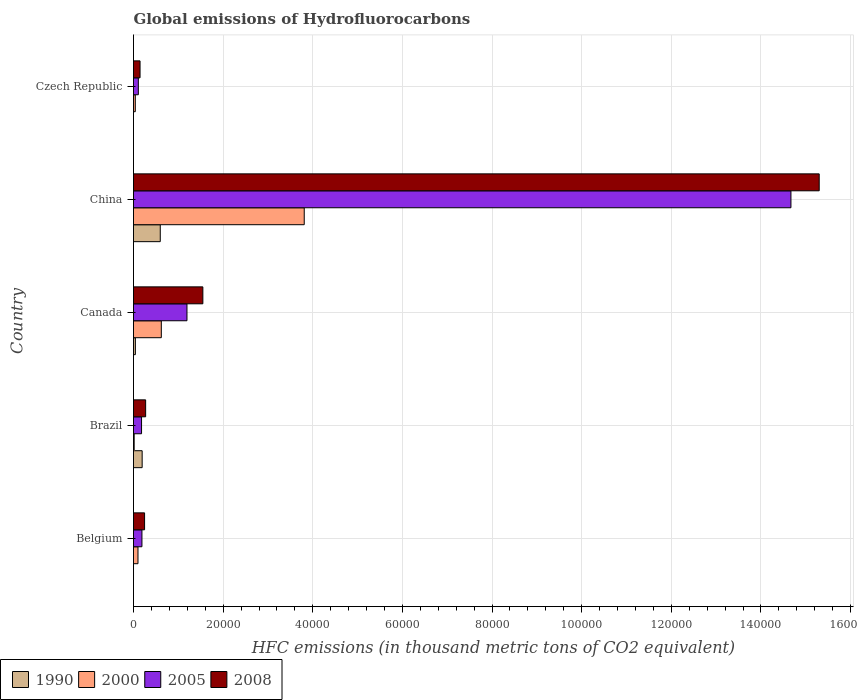How many different coloured bars are there?
Your answer should be very brief. 4. How many groups of bars are there?
Your answer should be very brief. 5. Are the number of bars per tick equal to the number of legend labels?
Your answer should be compact. Yes. How many bars are there on the 3rd tick from the top?
Give a very brief answer. 4. What is the global emissions of Hydrofluorocarbons in 2000 in Czech Republic?
Keep it short and to the point. 399.5. Across all countries, what is the maximum global emissions of Hydrofluorocarbons in 2005?
Your answer should be very brief. 1.47e+05. Across all countries, what is the minimum global emissions of Hydrofluorocarbons in 2005?
Your answer should be very brief. 1078.7. In which country was the global emissions of Hydrofluorocarbons in 2005 minimum?
Offer a terse response. Czech Republic. What is the total global emissions of Hydrofluorocarbons in 2008 in the graph?
Your answer should be compact. 1.75e+05. What is the difference between the global emissions of Hydrofluorocarbons in 2000 in Brazil and that in Canada?
Give a very brief answer. -6055.4. What is the difference between the global emissions of Hydrofluorocarbons in 2008 in Brazil and the global emissions of Hydrofluorocarbons in 1990 in Belgium?
Offer a very short reply. 2707. What is the average global emissions of Hydrofluorocarbons in 2000 per country?
Keep it short and to the point. 9168.28. What is the difference between the global emissions of Hydrofluorocarbons in 1990 and global emissions of Hydrofluorocarbons in 2005 in China?
Provide a short and direct response. -1.41e+05. In how many countries, is the global emissions of Hydrofluorocarbons in 1990 greater than 100000 thousand metric tons?
Provide a succinct answer. 0. What is the ratio of the global emissions of Hydrofluorocarbons in 2008 in Brazil to that in Canada?
Make the answer very short. 0.17. Is the global emissions of Hydrofluorocarbons in 1990 in Canada less than that in China?
Your response must be concise. Yes. What is the difference between the highest and the second highest global emissions of Hydrofluorocarbons in 2008?
Make the answer very short. 1.38e+05. What is the difference between the highest and the lowest global emissions of Hydrofluorocarbons in 1990?
Your response must be concise. 5970. In how many countries, is the global emissions of Hydrofluorocarbons in 1990 greater than the average global emissions of Hydrofluorocarbons in 1990 taken over all countries?
Offer a very short reply. 2. Is the sum of the global emissions of Hydrofluorocarbons in 2008 in Brazil and Czech Republic greater than the maximum global emissions of Hydrofluorocarbons in 2005 across all countries?
Your response must be concise. No. Is it the case that in every country, the sum of the global emissions of Hydrofluorocarbons in 1990 and global emissions of Hydrofluorocarbons in 2008 is greater than the sum of global emissions of Hydrofluorocarbons in 2000 and global emissions of Hydrofluorocarbons in 2005?
Provide a succinct answer. No. What does the 3rd bar from the bottom in Belgium represents?
Your response must be concise. 2005. Is it the case that in every country, the sum of the global emissions of Hydrofluorocarbons in 2000 and global emissions of Hydrofluorocarbons in 1990 is greater than the global emissions of Hydrofluorocarbons in 2008?
Provide a succinct answer. No. How many bars are there?
Offer a terse response. 20. Are all the bars in the graph horizontal?
Ensure brevity in your answer.  Yes. How many countries are there in the graph?
Ensure brevity in your answer.  5. Are the values on the major ticks of X-axis written in scientific E-notation?
Provide a short and direct response. No. Does the graph contain any zero values?
Provide a succinct answer. No. Does the graph contain grids?
Your answer should be compact. Yes. What is the title of the graph?
Ensure brevity in your answer.  Global emissions of Hydrofluorocarbons. What is the label or title of the X-axis?
Your answer should be compact. HFC emissions (in thousand metric tons of CO2 equivalent). What is the label or title of the Y-axis?
Keep it short and to the point. Country. What is the HFC emissions (in thousand metric tons of CO2 equivalent) in 2000 in Belgium?
Provide a short and direct response. 997.7. What is the HFC emissions (in thousand metric tons of CO2 equivalent) of 2005 in Belgium?
Provide a succinct answer. 1882.6. What is the HFC emissions (in thousand metric tons of CO2 equivalent) of 2008 in Belgium?
Provide a short and direct response. 2471.1. What is the HFC emissions (in thousand metric tons of CO2 equivalent) in 1990 in Brazil?
Offer a terse response. 1930.7. What is the HFC emissions (in thousand metric tons of CO2 equivalent) in 2000 in Brazil?
Your answer should be compact. 147.4. What is the HFC emissions (in thousand metric tons of CO2 equivalent) in 2005 in Brazil?
Ensure brevity in your answer.  1793.4. What is the HFC emissions (in thousand metric tons of CO2 equivalent) in 2008 in Brazil?
Your answer should be compact. 2707.5. What is the HFC emissions (in thousand metric tons of CO2 equivalent) in 1990 in Canada?
Your response must be concise. 418.5. What is the HFC emissions (in thousand metric tons of CO2 equivalent) of 2000 in Canada?
Your answer should be compact. 6202.8. What is the HFC emissions (in thousand metric tons of CO2 equivalent) in 2005 in Canada?
Offer a very short reply. 1.19e+04. What is the HFC emissions (in thousand metric tons of CO2 equivalent) in 2008 in Canada?
Offer a very short reply. 1.55e+04. What is the HFC emissions (in thousand metric tons of CO2 equivalent) in 1990 in China?
Your answer should be very brief. 5970.1. What is the HFC emissions (in thousand metric tons of CO2 equivalent) of 2000 in China?
Keep it short and to the point. 3.81e+04. What is the HFC emissions (in thousand metric tons of CO2 equivalent) of 2005 in China?
Your answer should be compact. 1.47e+05. What is the HFC emissions (in thousand metric tons of CO2 equivalent) of 2008 in China?
Keep it short and to the point. 1.53e+05. What is the HFC emissions (in thousand metric tons of CO2 equivalent) of 1990 in Czech Republic?
Provide a short and direct response. 0.1. What is the HFC emissions (in thousand metric tons of CO2 equivalent) of 2000 in Czech Republic?
Your answer should be compact. 399.5. What is the HFC emissions (in thousand metric tons of CO2 equivalent) of 2005 in Czech Republic?
Ensure brevity in your answer.  1078.7. What is the HFC emissions (in thousand metric tons of CO2 equivalent) of 2008 in Czech Republic?
Ensure brevity in your answer.  1459. Across all countries, what is the maximum HFC emissions (in thousand metric tons of CO2 equivalent) in 1990?
Provide a short and direct response. 5970.1. Across all countries, what is the maximum HFC emissions (in thousand metric tons of CO2 equivalent) of 2000?
Your response must be concise. 3.81e+04. Across all countries, what is the maximum HFC emissions (in thousand metric tons of CO2 equivalent) in 2005?
Your response must be concise. 1.47e+05. Across all countries, what is the maximum HFC emissions (in thousand metric tons of CO2 equivalent) in 2008?
Provide a succinct answer. 1.53e+05. Across all countries, what is the minimum HFC emissions (in thousand metric tons of CO2 equivalent) of 2000?
Make the answer very short. 147.4. Across all countries, what is the minimum HFC emissions (in thousand metric tons of CO2 equivalent) in 2005?
Offer a terse response. 1078.7. Across all countries, what is the minimum HFC emissions (in thousand metric tons of CO2 equivalent) of 2008?
Your response must be concise. 1459. What is the total HFC emissions (in thousand metric tons of CO2 equivalent) in 1990 in the graph?
Provide a succinct answer. 8319.9. What is the total HFC emissions (in thousand metric tons of CO2 equivalent) in 2000 in the graph?
Offer a very short reply. 4.58e+04. What is the total HFC emissions (in thousand metric tons of CO2 equivalent) of 2005 in the graph?
Ensure brevity in your answer.  1.63e+05. What is the total HFC emissions (in thousand metric tons of CO2 equivalent) of 2008 in the graph?
Ensure brevity in your answer.  1.75e+05. What is the difference between the HFC emissions (in thousand metric tons of CO2 equivalent) of 1990 in Belgium and that in Brazil?
Provide a succinct answer. -1930.2. What is the difference between the HFC emissions (in thousand metric tons of CO2 equivalent) of 2000 in Belgium and that in Brazil?
Give a very brief answer. 850.3. What is the difference between the HFC emissions (in thousand metric tons of CO2 equivalent) in 2005 in Belgium and that in Brazil?
Offer a terse response. 89.2. What is the difference between the HFC emissions (in thousand metric tons of CO2 equivalent) of 2008 in Belgium and that in Brazil?
Provide a short and direct response. -236.4. What is the difference between the HFC emissions (in thousand metric tons of CO2 equivalent) in 1990 in Belgium and that in Canada?
Ensure brevity in your answer.  -418. What is the difference between the HFC emissions (in thousand metric tons of CO2 equivalent) of 2000 in Belgium and that in Canada?
Keep it short and to the point. -5205.1. What is the difference between the HFC emissions (in thousand metric tons of CO2 equivalent) in 2005 in Belgium and that in Canada?
Your response must be concise. -1.00e+04. What is the difference between the HFC emissions (in thousand metric tons of CO2 equivalent) in 2008 in Belgium and that in Canada?
Your answer should be very brief. -1.30e+04. What is the difference between the HFC emissions (in thousand metric tons of CO2 equivalent) of 1990 in Belgium and that in China?
Your response must be concise. -5969.6. What is the difference between the HFC emissions (in thousand metric tons of CO2 equivalent) of 2000 in Belgium and that in China?
Give a very brief answer. -3.71e+04. What is the difference between the HFC emissions (in thousand metric tons of CO2 equivalent) of 2005 in Belgium and that in China?
Your answer should be very brief. -1.45e+05. What is the difference between the HFC emissions (in thousand metric tons of CO2 equivalent) in 2008 in Belgium and that in China?
Provide a succinct answer. -1.51e+05. What is the difference between the HFC emissions (in thousand metric tons of CO2 equivalent) in 1990 in Belgium and that in Czech Republic?
Provide a short and direct response. 0.4. What is the difference between the HFC emissions (in thousand metric tons of CO2 equivalent) of 2000 in Belgium and that in Czech Republic?
Keep it short and to the point. 598.2. What is the difference between the HFC emissions (in thousand metric tons of CO2 equivalent) of 2005 in Belgium and that in Czech Republic?
Give a very brief answer. 803.9. What is the difference between the HFC emissions (in thousand metric tons of CO2 equivalent) in 2008 in Belgium and that in Czech Republic?
Your response must be concise. 1012.1. What is the difference between the HFC emissions (in thousand metric tons of CO2 equivalent) of 1990 in Brazil and that in Canada?
Keep it short and to the point. 1512.2. What is the difference between the HFC emissions (in thousand metric tons of CO2 equivalent) of 2000 in Brazil and that in Canada?
Provide a succinct answer. -6055.4. What is the difference between the HFC emissions (in thousand metric tons of CO2 equivalent) of 2005 in Brazil and that in Canada?
Offer a very short reply. -1.01e+04. What is the difference between the HFC emissions (in thousand metric tons of CO2 equivalent) of 2008 in Brazil and that in Canada?
Your answer should be compact. -1.28e+04. What is the difference between the HFC emissions (in thousand metric tons of CO2 equivalent) in 1990 in Brazil and that in China?
Offer a terse response. -4039.4. What is the difference between the HFC emissions (in thousand metric tons of CO2 equivalent) in 2000 in Brazil and that in China?
Offer a very short reply. -3.79e+04. What is the difference between the HFC emissions (in thousand metric tons of CO2 equivalent) of 2005 in Brazil and that in China?
Ensure brevity in your answer.  -1.45e+05. What is the difference between the HFC emissions (in thousand metric tons of CO2 equivalent) of 2008 in Brazil and that in China?
Your response must be concise. -1.50e+05. What is the difference between the HFC emissions (in thousand metric tons of CO2 equivalent) in 1990 in Brazil and that in Czech Republic?
Ensure brevity in your answer.  1930.6. What is the difference between the HFC emissions (in thousand metric tons of CO2 equivalent) of 2000 in Brazil and that in Czech Republic?
Offer a very short reply. -252.1. What is the difference between the HFC emissions (in thousand metric tons of CO2 equivalent) in 2005 in Brazil and that in Czech Republic?
Your answer should be very brief. 714.7. What is the difference between the HFC emissions (in thousand metric tons of CO2 equivalent) of 2008 in Brazil and that in Czech Republic?
Make the answer very short. 1248.5. What is the difference between the HFC emissions (in thousand metric tons of CO2 equivalent) in 1990 in Canada and that in China?
Your answer should be compact. -5551.6. What is the difference between the HFC emissions (in thousand metric tons of CO2 equivalent) in 2000 in Canada and that in China?
Offer a terse response. -3.19e+04. What is the difference between the HFC emissions (in thousand metric tons of CO2 equivalent) in 2005 in Canada and that in China?
Provide a succinct answer. -1.35e+05. What is the difference between the HFC emissions (in thousand metric tons of CO2 equivalent) in 2008 in Canada and that in China?
Keep it short and to the point. -1.38e+05. What is the difference between the HFC emissions (in thousand metric tons of CO2 equivalent) in 1990 in Canada and that in Czech Republic?
Provide a short and direct response. 418.4. What is the difference between the HFC emissions (in thousand metric tons of CO2 equivalent) in 2000 in Canada and that in Czech Republic?
Ensure brevity in your answer.  5803.3. What is the difference between the HFC emissions (in thousand metric tons of CO2 equivalent) in 2005 in Canada and that in Czech Republic?
Keep it short and to the point. 1.08e+04. What is the difference between the HFC emissions (in thousand metric tons of CO2 equivalent) in 2008 in Canada and that in Czech Republic?
Keep it short and to the point. 1.40e+04. What is the difference between the HFC emissions (in thousand metric tons of CO2 equivalent) in 1990 in China and that in Czech Republic?
Your answer should be compact. 5970. What is the difference between the HFC emissions (in thousand metric tons of CO2 equivalent) of 2000 in China and that in Czech Republic?
Your answer should be very brief. 3.77e+04. What is the difference between the HFC emissions (in thousand metric tons of CO2 equivalent) of 2005 in China and that in Czech Republic?
Ensure brevity in your answer.  1.46e+05. What is the difference between the HFC emissions (in thousand metric tons of CO2 equivalent) in 2008 in China and that in Czech Republic?
Ensure brevity in your answer.  1.52e+05. What is the difference between the HFC emissions (in thousand metric tons of CO2 equivalent) of 1990 in Belgium and the HFC emissions (in thousand metric tons of CO2 equivalent) of 2000 in Brazil?
Ensure brevity in your answer.  -146.9. What is the difference between the HFC emissions (in thousand metric tons of CO2 equivalent) in 1990 in Belgium and the HFC emissions (in thousand metric tons of CO2 equivalent) in 2005 in Brazil?
Provide a short and direct response. -1792.9. What is the difference between the HFC emissions (in thousand metric tons of CO2 equivalent) of 1990 in Belgium and the HFC emissions (in thousand metric tons of CO2 equivalent) of 2008 in Brazil?
Your answer should be compact. -2707. What is the difference between the HFC emissions (in thousand metric tons of CO2 equivalent) of 2000 in Belgium and the HFC emissions (in thousand metric tons of CO2 equivalent) of 2005 in Brazil?
Offer a very short reply. -795.7. What is the difference between the HFC emissions (in thousand metric tons of CO2 equivalent) of 2000 in Belgium and the HFC emissions (in thousand metric tons of CO2 equivalent) of 2008 in Brazil?
Your answer should be very brief. -1709.8. What is the difference between the HFC emissions (in thousand metric tons of CO2 equivalent) in 2005 in Belgium and the HFC emissions (in thousand metric tons of CO2 equivalent) in 2008 in Brazil?
Your answer should be very brief. -824.9. What is the difference between the HFC emissions (in thousand metric tons of CO2 equivalent) in 1990 in Belgium and the HFC emissions (in thousand metric tons of CO2 equivalent) in 2000 in Canada?
Provide a short and direct response. -6202.3. What is the difference between the HFC emissions (in thousand metric tons of CO2 equivalent) of 1990 in Belgium and the HFC emissions (in thousand metric tons of CO2 equivalent) of 2005 in Canada?
Make the answer very short. -1.19e+04. What is the difference between the HFC emissions (in thousand metric tons of CO2 equivalent) of 1990 in Belgium and the HFC emissions (in thousand metric tons of CO2 equivalent) of 2008 in Canada?
Ensure brevity in your answer.  -1.55e+04. What is the difference between the HFC emissions (in thousand metric tons of CO2 equivalent) in 2000 in Belgium and the HFC emissions (in thousand metric tons of CO2 equivalent) in 2005 in Canada?
Ensure brevity in your answer.  -1.09e+04. What is the difference between the HFC emissions (in thousand metric tons of CO2 equivalent) in 2000 in Belgium and the HFC emissions (in thousand metric tons of CO2 equivalent) in 2008 in Canada?
Provide a short and direct response. -1.45e+04. What is the difference between the HFC emissions (in thousand metric tons of CO2 equivalent) of 2005 in Belgium and the HFC emissions (in thousand metric tons of CO2 equivalent) of 2008 in Canada?
Your answer should be very brief. -1.36e+04. What is the difference between the HFC emissions (in thousand metric tons of CO2 equivalent) in 1990 in Belgium and the HFC emissions (in thousand metric tons of CO2 equivalent) in 2000 in China?
Provide a short and direct response. -3.81e+04. What is the difference between the HFC emissions (in thousand metric tons of CO2 equivalent) of 1990 in Belgium and the HFC emissions (in thousand metric tons of CO2 equivalent) of 2005 in China?
Provide a succinct answer. -1.47e+05. What is the difference between the HFC emissions (in thousand metric tons of CO2 equivalent) in 1990 in Belgium and the HFC emissions (in thousand metric tons of CO2 equivalent) in 2008 in China?
Your answer should be very brief. -1.53e+05. What is the difference between the HFC emissions (in thousand metric tons of CO2 equivalent) in 2000 in Belgium and the HFC emissions (in thousand metric tons of CO2 equivalent) in 2005 in China?
Ensure brevity in your answer.  -1.46e+05. What is the difference between the HFC emissions (in thousand metric tons of CO2 equivalent) in 2000 in Belgium and the HFC emissions (in thousand metric tons of CO2 equivalent) in 2008 in China?
Your response must be concise. -1.52e+05. What is the difference between the HFC emissions (in thousand metric tons of CO2 equivalent) in 2005 in Belgium and the HFC emissions (in thousand metric tons of CO2 equivalent) in 2008 in China?
Provide a succinct answer. -1.51e+05. What is the difference between the HFC emissions (in thousand metric tons of CO2 equivalent) in 1990 in Belgium and the HFC emissions (in thousand metric tons of CO2 equivalent) in 2000 in Czech Republic?
Provide a succinct answer. -399. What is the difference between the HFC emissions (in thousand metric tons of CO2 equivalent) in 1990 in Belgium and the HFC emissions (in thousand metric tons of CO2 equivalent) in 2005 in Czech Republic?
Your answer should be compact. -1078.2. What is the difference between the HFC emissions (in thousand metric tons of CO2 equivalent) of 1990 in Belgium and the HFC emissions (in thousand metric tons of CO2 equivalent) of 2008 in Czech Republic?
Your answer should be compact. -1458.5. What is the difference between the HFC emissions (in thousand metric tons of CO2 equivalent) of 2000 in Belgium and the HFC emissions (in thousand metric tons of CO2 equivalent) of 2005 in Czech Republic?
Make the answer very short. -81. What is the difference between the HFC emissions (in thousand metric tons of CO2 equivalent) of 2000 in Belgium and the HFC emissions (in thousand metric tons of CO2 equivalent) of 2008 in Czech Republic?
Offer a terse response. -461.3. What is the difference between the HFC emissions (in thousand metric tons of CO2 equivalent) in 2005 in Belgium and the HFC emissions (in thousand metric tons of CO2 equivalent) in 2008 in Czech Republic?
Give a very brief answer. 423.6. What is the difference between the HFC emissions (in thousand metric tons of CO2 equivalent) of 1990 in Brazil and the HFC emissions (in thousand metric tons of CO2 equivalent) of 2000 in Canada?
Ensure brevity in your answer.  -4272.1. What is the difference between the HFC emissions (in thousand metric tons of CO2 equivalent) in 1990 in Brazil and the HFC emissions (in thousand metric tons of CO2 equivalent) in 2005 in Canada?
Give a very brief answer. -9997.7. What is the difference between the HFC emissions (in thousand metric tons of CO2 equivalent) of 1990 in Brazil and the HFC emissions (in thousand metric tons of CO2 equivalent) of 2008 in Canada?
Give a very brief answer. -1.35e+04. What is the difference between the HFC emissions (in thousand metric tons of CO2 equivalent) in 2000 in Brazil and the HFC emissions (in thousand metric tons of CO2 equivalent) in 2005 in Canada?
Your response must be concise. -1.18e+04. What is the difference between the HFC emissions (in thousand metric tons of CO2 equivalent) in 2000 in Brazil and the HFC emissions (in thousand metric tons of CO2 equivalent) in 2008 in Canada?
Give a very brief answer. -1.53e+04. What is the difference between the HFC emissions (in thousand metric tons of CO2 equivalent) of 2005 in Brazil and the HFC emissions (in thousand metric tons of CO2 equivalent) of 2008 in Canada?
Ensure brevity in your answer.  -1.37e+04. What is the difference between the HFC emissions (in thousand metric tons of CO2 equivalent) of 1990 in Brazil and the HFC emissions (in thousand metric tons of CO2 equivalent) of 2000 in China?
Your response must be concise. -3.62e+04. What is the difference between the HFC emissions (in thousand metric tons of CO2 equivalent) in 1990 in Brazil and the HFC emissions (in thousand metric tons of CO2 equivalent) in 2005 in China?
Your answer should be very brief. -1.45e+05. What is the difference between the HFC emissions (in thousand metric tons of CO2 equivalent) of 1990 in Brazil and the HFC emissions (in thousand metric tons of CO2 equivalent) of 2008 in China?
Your response must be concise. -1.51e+05. What is the difference between the HFC emissions (in thousand metric tons of CO2 equivalent) of 2000 in Brazil and the HFC emissions (in thousand metric tons of CO2 equivalent) of 2005 in China?
Provide a succinct answer. -1.47e+05. What is the difference between the HFC emissions (in thousand metric tons of CO2 equivalent) in 2000 in Brazil and the HFC emissions (in thousand metric tons of CO2 equivalent) in 2008 in China?
Give a very brief answer. -1.53e+05. What is the difference between the HFC emissions (in thousand metric tons of CO2 equivalent) of 2005 in Brazil and the HFC emissions (in thousand metric tons of CO2 equivalent) of 2008 in China?
Your answer should be very brief. -1.51e+05. What is the difference between the HFC emissions (in thousand metric tons of CO2 equivalent) of 1990 in Brazil and the HFC emissions (in thousand metric tons of CO2 equivalent) of 2000 in Czech Republic?
Offer a terse response. 1531.2. What is the difference between the HFC emissions (in thousand metric tons of CO2 equivalent) of 1990 in Brazil and the HFC emissions (in thousand metric tons of CO2 equivalent) of 2005 in Czech Republic?
Your response must be concise. 852. What is the difference between the HFC emissions (in thousand metric tons of CO2 equivalent) of 1990 in Brazil and the HFC emissions (in thousand metric tons of CO2 equivalent) of 2008 in Czech Republic?
Your answer should be very brief. 471.7. What is the difference between the HFC emissions (in thousand metric tons of CO2 equivalent) in 2000 in Brazil and the HFC emissions (in thousand metric tons of CO2 equivalent) in 2005 in Czech Republic?
Offer a very short reply. -931.3. What is the difference between the HFC emissions (in thousand metric tons of CO2 equivalent) in 2000 in Brazil and the HFC emissions (in thousand metric tons of CO2 equivalent) in 2008 in Czech Republic?
Provide a succinct answer. -1311.6. What is the difference between the HFC emissions (in thousand metric tons of CO2 equivalent) of 2005 in Brazil and the HFC emissions (in thousand metric tons of CO2 equivalent) of 2008 in Czech Republic?
Provide a short and direct response. 334.4. What is the difference between the HFC emissions (in thousand metric tons of CO2 equivalent) in 1990 in Canada and the HFC emissions (in thousand metric tons of CO2 equivalent) in 2000 in China?
Your answer should be very brief. -3.77e+04. What is the difference between the HFC emissions (in thousand metric tons of CO2 equivalent) in 1990 in Canada and the HFC emissions (in thousand metric tons of CO2 equivalent) in 2005 in China?
Give a very brief answer. -1.46e+05. What is the difference between the HFC emissions (in thousand metric tons of CO2 equivalent) in 1990 in Canada and the HFC emissions (in thousand metric tons of CO2 equivalent) in 2008 in China?
Provide a short and direct response. -1.53e+05. What is the difference between the HFC emissions (in thousand metric tons of CO2 equivalent) of 2000 in Canada and the HFC emissions (in thousand metric tons of CO2 equivalent) of 2005 in China?
Your answer should be very brief. -1.40e+05. What is the difference between the HFC emissions (in thousand metric tons of CO2 equivalent) of 2000 in Canada and the HFC emissions (in thousand metric tons of CO2 equivalent) of 2008 in China?
Provide a succinct answer. -1.47e+05. What is the difference between the HFC emissions (in thousand metric tons of CO2 equivalent) of 2005 in Canada and the HFC emissions (in thousand metric tons of CO2 equivalent) of 2008 in China?
Provide a succinct answer. -1.41e+05. What is the difference between the HFC emissions (in thousand metric tons of CO2 equivalent) of 1990 in Canada and the HFC emissions (in thousand metric tons of CO2 equivalent) of 2000 in Czech Republic?
Ensure brevity in your answer.  19. What is the difference between the HFC emissions (in thousand metric tons of CO2 equivalent) of 1990 in Canada and the HFC emissions (in thousand metric tons of CO2 equivalent) of 2005 in Czech Republic?
Ensure brevity in your answer.  -660.2. What is the difference between the HFC emissions (in thousand metric tons of CO2 equivalent) of 1990 in Canada and the HFC emissions (in thousand metric tons of CO2 equivalent) of 2008 in Czech Republic?
Offer a terse response. -1040.5. What is the difference between the HFC emissions (in thousand metric tons of CO2 equivalent) of 2000 in Canada and the HFC emissions (in thousand metric tons of CO2 equivalent) of 2005 in Czech Republic?
Make the answer very short. 5124.1. What is the difference between the HFC emissions (in thousand metric tons of CO2 equivalent) in 2000 in Canada and the HFC emissions (in thousand metric tons of CO2 equivalent) in 2008 in Czech Republic?
Ensure brevity in your answer.  4743.8. What is the difference between the HFC emissions (in thousand metric tons of CO2 equivalent) of 2005 in Canada and the HFC emissions (in thousand metric tons of CO2 equivalent) of 2008 in Czech Republic?
Give a very brief answer. 1.05e+04. What is the difference between the HFC emissions (in thousand metric tons of CO2 equivalent) in 1990 in China and the HFC emissions (in thousand metric tons of CO2 equivalent) in 2000 in Czech Republic?
Make the answer very short. 5570.6. What is the difference between the HFC emissions (in thousand metric tons of CO2 equivalent) in 1990 in China and the HFC emissions (in thousand metric tons of CO2 equivalent) in 2005 in Czech Republic?
Offer a terse response. 4891.4. What is the difference between the HFC emissions (in thousand metric tons of CO2 equivalent) in 1990 in China and the HFC emissions (in thousand metric tons of CO2 equivalent) in 2008 in Czech Republic?
Your answer should be very brief. 4511.1. What is the difference between the HFC emissions (in thousand metric tons of CO2 equivalent) in 2000 in China and the HFC emissions (in thousand metric tons of CO2 equivalent) in 2005 in Czech Republic?
Give a very brief answer. 3.70e+04. What is the difference between the HFC emissions (in thousand metric tons of CO2 equivalent) of 2000 in China and the HFC emissions (in thousand metric tons of CO2 equivalent) of 2008 in Czech Republic?
Ensure brevity in your answer.  3.66e+04. What is the difference between the HFC emissions (in thousand metric tons of CO2 equivalent) in 2005 in China and the HFC emissions (in thousand metric tons of CO2 equivalent) in 2008 in Czech Republic?
Your answer should be very brief. 1.45e+05. What is the average HFC emissions (in thousand metric tons of CO2 equivalent) in 1990 per country?
Your response must be concise. 1663.98. What is the average HFC emissions (in thousand metric tons of CO2 equivalent) of 2000 per country?
Provide a succinct answer. 9168.28. What is the average HFC emissions (in thousand metric tons of CO2 equivalent) in 2005 per country?
Provide a succinct answer. 3.27e+04. What is the average HFC emissions (in thousand metric tons of CO2 equivalent) of 2008 per country?
Give a very brief answer. 3.50e+04. What is the difference between the HFC emissions (in thousand metric tons of CO2 equivalent) of 1990 and HFC emissions (in thousand metric tons of CO2 equivalent) of 2000 in Belgium?
Ensure brevity in your answer.  -997.2. What is the difference between the HFC emissions (in thousand metric tons of CO2 equivalent) in 1990 and HFC emissions (in thousand metric tons of CO2 equivalent) in 2005 in Belgium?
Give a very brief answer. -1882.1. What is the difference between the HFC emissions (in thousand metric tons of CO2 equivalent) in 1990 and HFC emissions (in thousand metric tons of CO2 equivalent) in 2008 in Belgium?
Offer a terse response. -2470.6. What is the difference between the HFC emissions (in thousand metric tons of CO2 equivalent) of 2000 and HFC emissions (in thousand metric tons of CO2 equivalent) of 2005 in Belgium?
Your response must be concise. -884.9. What is the difference between the HFC emissions (in thousand metric tons of CO2 equivalent) of 2000 and HFC emissions (in thousand metric tons of CO2 equivalent) of 2008 in Belgium?
Your answer should be compact. -1473.4. What is the difference between the HFC emissions (in thousand metric tons of CO2 equivalent) in 2005 and HFC emissions (in thousand metric tons of CO2 equivalent) in 2008 in Belgium?
Provide a short and direct response. -588.5. What is the difference between the HFC emissions (in thousand metric tons of CO2 equivalent) of 1990 and HFC emissions (in thousand metric tons of CO2 equivalent) of 2000 in Brazil?
Make the answer very short. 1783.3. What is the difference between the HFC emissions (in thousand metric tons of CO2 equivalent) in 1990 and HFC emissions (in thousand metric tons of CO2 equivalent) in 2005 in Brazil?
Give a very brief answer. 137.3. What is the difference between the HFC emissions (in thousand metric tons of CO2 equivalent) in 1990 and HFC emissions (in thousand metric tons of CO2 equivalent) in 2008 in Brazil?
Offer a terse response. -776.8. What is the difference between the HFC emissions (in thousand metric tons of CO2 equivalent) of 2000 and HFC emissions (in thousand metric tons of CO2 equivalent) of 2005 in Brazil?
Your answer should be compact. -1646. What is the difference between the HFC emissions (in thousand metric tons of CO2 equivalent) in 2000 and HFC emissions (in thousand metric tons of CO2 equivalent) in 2008 in Brazil?
Your response must be concise. -2560.1. What is the difference between the HFC emissions (in thousand metric tons of CO2 equivalent) in 2005 and HFC emissions (in thousand metric tons of CO2 equivalent) in 2008 in Brazil?
Provide a succinct answer. -914.1. What is the difference between the HFC emissions (in thousand metric tons of CO2 equivalent) in 1990 and HFC emissions (in thousand metric tons of CO2 equivalent) in 2000 in Canada?
Your answer should be very brief. -5784.3. What is the difference between the HFC emissions (in thousand metric tons of CO2 equivalent) of 1990 and HFC emissions (in thousand metric tons of CO2 equivalent) of 2005 in Canada?
Offer a very short reply. -1.15e+04. What is the difference between the HFC emissions (in thousand metric tons of CO2 equivalent) in 1990 and HFC emissions (in thousand metric tons of CO2 equivalent) in 2008 in Canada?
Provide a succinct answer. -1.51e+04. What is the difference between the HFC emissions (in thousand metric tons of CO2 equivalent) in 2000 and HFC emissions (in thousand metric tons of CO2 equivalent) in 2005 in Canada?
Give a very brief answer. -5725.6. What is the difference between the HFC emissions (in thousand metric tons of CO2 equivalent) of 2000 and HFC emissions (in thousand metric tons of CO2 equivalent) of 2008 in Canada?
Ensure brevity in your answer.  -9272. What is the difference between the HFC emissions (in thousand metric tons of CO2 equivalent) in 2005 and HFC emissions (in thousand metric tons of CO2 equivalent) in 2008 in Canada?
Offer a terse response. -3546.4. What is the difference between the HFC emissions (in thousand metric tons of CO2 equivalent) of 1990 and HFC emissions (in thousand metric tons of CO2 equivalent) of 2000 in China?
Give a very brief answer. -3.21e+04. What is the difference between the HFC emissions (in thousand metric tons of CO2 equivalent) in 1990 and HFC emissions (in thousand metric tons of CO2 equivalent) in 2005 in China?
Your answer should be very brief. -1.41e+05. What is the difference between the HFC emissions (in thousand metric tons of CO2 equivalent) in 1990 and HFC emissions (in thousand metric tons of CO2 equivalent) in 2008 in China?
Make the answer very short. -1.47e+05. What is the difference between the HFC emissions (in thousand metric tons of CO2 equivalent) in 2000 and HFC emissions (in thousand metric tons of CO2 equivalent) in 2005 in China?
Your answer should be very brief. -1.09e+05. What is the difference between the HFC emissions (in thousand metric tons of CO2 equivalent) in 2000 and HFC emissions (in thousand metric tons of CO2 equivalent) in 2008 in China?
Offer a terse response. -1.15e+05. What is the difference between the HFC emissions (in thousand metric tons of CO2 equivalent) of 2005 and HFC emissions (in thousand metric tons of CO2 equivalent) of 2008 in China?
Offer a very short reply. -6309. What is the difference between the HFC emissions (in thousand metric tons of CO2 equivalent) of 1990 and HFC emissions (in thousand metric tons of CO2 equivalent) of 2000 in Czech Republic?
Keep it short and to the point. -399.4. What is the difference between the HFC emissions (in thousand metric tons of CO2 equivalent) of 1990 and HFC emissions (in thousand metric tons of CO2 equivalent) of 2005 in Czech Republic?
Offer a very short reply. -1078.6. What is the difference between the HFC emissions (in thousand metric tons of CO2 equivalent) in 1990 and HFC emissions (in thousand metric tons of CO2 equivalent) in 2008 in Czech Republic?
Give a very brief answer. -1458.9. What is the difference between the HFC emissions (in thousand metric tons of CO2 equivalent) of 2000 and HFC emissions (in thousand metric tons of CO2 equivalent) of 2005 in Czech Republic?
Ensure brevity in your answer.  -679.2. What is the difference between the HFC emissions (in thousand metric tons of CO2 equivalent) in 2000 and HFC emissions (in thousand metric tons of CO2 equivalent) in 2008 in Czech Republic?
Provide a succinct answer. -1059.5. What is the difference between the HFC emissions (in thousand metric tons of CO2 equivalent) in 2005 and HFC emissions (in thousand metric tons of CO2 equivalent) in 2008 in Czech Republic?
Provide a succinct answer. -380.3. What is the ratio of the HFC emissions (in thousand metric tons of CO2 equivalent) of 2000 in Belgium to that in Brazil?
Keep it short and to the point. 6.77. What is the ratio of the HFC emissions (in thousand metric tons of CO2 equivalent) of 2005 in Belgium to that in Brazil?
Your answer should be very brief. 1.05. What is the ratio of the HFC emissions (in thousand metric tons of CO2 equivalent) of 2008 in Belgium to that in Brazil?
Your answer should be very brief. 0.91. What is the ratio of the HFC emissions (in thousand metric tons of CO2 equivalent) of 1990 in Belgium to that in Canada?
Give a very brief answer. 0. What is the ratio of the HFC emissions (in thousand metric tons of CO2 equivalent) in 2000 in Belgium to that in Canada?
Offer a very short reply. 0.16. What is the ratio of the HFC emissions (in thousand metric tons of CO2 equivalent) of 2005 in Belgium to that in Canada?
Provide a short and direct response. 0.16. What is the ratio of the HFC emissions (in thousand metric tons of CO2 equivalent) in 2008 in Belgium to that in Canada?
Provide a short and direct response. 0.16. What is the ratio of the HFC emissions (in thousand metric tons of CO2 equivalent) in 1990 in Belgium to that in China?
Your answer should be compact. 0. What is the ratio of the HFC emissions (in thousand metric tons of CO2 equivalent) in 2000 in Belgium to that in China?
Offer a terse response. 0.03. What is the ratio of the HFC emissions (in thousand metric tons of CO2 equivalent) of 2005 in Belgium to that in China?
Ensure brevity in your answer.  0.01. What is the ratio of the HFC emissions (in thousand metric tons of CO2 equivalent) in 2008 in Belgium to that in China?
Your answer should be compact. 0.02. What is the ratio of the HFC emissions (in thousand metric tons of CO2 equivalent) in 1990 in Belgium to that in Czech Republic?
Offer a terse response. 5. What is the ratio of the HFC emissions (in thousand metric tons of CO2 equivalent) of 2000 in Belgium to that in Czech Republic?
Offer a terse response. 2.5. What is the ratio of the HFC emissions (in thousand metric tons of CO2 equivalent) in 2005 in Belgium to that in Czech Republic?
Offer a very short reply. 1.75. What is the ratio of the HFC emissions (in thousand metric tons of CO2 equivalent) in 2008 in Belgium to that in Czech Republic?
Provide a succinct answer. 1.69. What is the ratio of the HFC emissions (in thousand metric tons of CO2 equivalent) in 1990 in Brazil to that in Canada?
Offer a terse response. 4.61. What is the ratio of the HFC emissions (in thousand metric tons of CO2 equivalent) of 2000 in Brazil to that in Canada?
Offer a very short reply. 0.02. What is the ratio of the HFC emissions (in thousand metric tons of CO2 equivalent) of 2005 in Brazil to that in Canada?
Provide a succinct answer. 0.15. What is the ratio of the HFC emissions (in thousand metric tons of CO2 equivalent) in 2008 in Brazil to that in Canada?
Keep it short and to the point. 0.17. What is the ratio of the HFC emissions (in thousand metric tons of CO2 equivalent) of 1990 in Brazil to that in China?
Offer a terse response. 0.32. What is the ratio of the HFC emissions (in thousand metric tons of CO2 equivalent) of 2000 in Brazil to that in China?
Ensure brevity in your answer.  0. What is the ratio of the HFC emissions (in thousand metric tons of CO2 equivalent) of 2005 in Brazil to that in China?
Provide a short and direct response. 0.01. What is the ratio of the HFC emissions (in thousand metric tons of CO2 equivalent) in 2008 in Brazil to that in China?
Your response must be concise. 0.02. What is the ratio of the HFC emissions (in thousand metric tons of CO2 equivalent) in 1990 in Brazil to that in Czech Republic?
Your answer should be compact. 1.93e+04. What is the ratio of the HFC emissions (in thousand metric tons of CO2 equivalent) of 2000 in Brazil to that in Czech Republic?
Offer a very short reply. 0.37. What is the ratio of the HFC emissions (in thousand metric tons of CO2 equivalent) of 2005 in Brazil to that in Czech Republic?
Ensure brevity in your answer.  1.66. What is the ratio of the HFC emissions (in thousand metric tons of CO2 equivalent) in 2008 in Brazil to that in Czech Republic?
Keep it short and to the point. 1.86. What is the ratio of the HFC emissions (in thousand metric tons of CO2 equivalent) in 1990 in Canada to that in China?
Ensure brevity in your answer.  0.07. What is the ratio of the HFC emissions (in thousand metric tons of CO2 equivalent) of 2000 in Canada to that in China?
Your answer should be very brief. 0.16. What is the ratio of the HFC emissions (in thousand metric tons of CO2 equivalent) in 2005 in Canada to that in China?
Offer a terse response. 0.08. What is the ratio of the HFC emissions (in thousand metric tons of CO2 equivalent) in 2008 in Canada to that in China?
Your answer should be very brief. 0.1. What is the ratio of the HFC emissions (in thousand metric tons of CO2 equivalent) of 1990 in Canada to that in Czech Republic?
Provide a short and direct response. 4185. What is the ratio of the HFC emissions (in thousand metric tons of CO2 equivalent) in 2000 in Canada to that in Czech Republic?
Ensure brevity in your answer.  15.53. What is the ratio of the HFC emissions (in thousand metric tons of CO2 equivalent) of 2005 in Canada to that in Czech Republic?
Give a very brief answer. 11.06. What is the ratio of the HFC emissions (in thousand metric tons of CO2 equivalent) in 2008 in Canada to that in Czech Republic?
Provide a short and direct response. 10.61. What is the ratio of the HFC emissions (in thousand metric tons of CO2 equivalent) in 1990 in China to that in Czech Republic?
Provide a short and direct response. 5.97e+04. What is the ratio of the HFC emissions (in thousand metric tons of CO2 equivalent) of 2000 in China to that in Czech Republic?
Provide a succinct answer. 95.35. What is the ratio of the HFC emissions (in thousand metric tons of CO2 equivalent) of 2005 in China to that in Czech Republic?
Ensure brevity in your answer.  135.99. What is the ratio of the HFC emissions (in thousand metric tons of CO2 equivalent) of 2008 in China to that in Czech Republic?
Offer a terse response. 104.87. What is the difference between the highest and the second highest HFC emissions (in thousand metric tons of CO2 equivalent) in 1990?
Provide a succinct answer. 4039.4. What is the difference between the highest and the second highest HFC emissions (in thousand metric tons of CO2 equivalent) of 2000?
Offer a very short reply. 3.19e+04. What is the difference between the highest and the second highest HFC emissions (in thousand metric tons of CO2 equivalent) of 2005?
Keep it short and to the point. 1.35e+05. What is the difference between the highest and the second highest HFC emissions (in thousand metric tons of CO2 equivalent) in 2008?
Ensure brevity in your answer.  1.38e+05. What is the difference between the highest and the lowest HFC emissions (in thousand metric tons of CO2 equivalent) in 1990?
Make the answer very short. 5970. What is the difference between the highest and the lowest HFC emissions (in thousand metric tons of CO2 equivalent) in 2000?
Make the answer very short. 3.79e+04. What is the difference between the highest and the lowest HFC emissions (in thousand metric tons of CO2 equivalent) of 2005?
Provide a succinct answer. 1.46e+05. What is the difference between the highest and the lowest HFC emissions (in thousand metric tons of CO2 equivalent) of 2008?
Make the answer very short. 1.52e+05. 